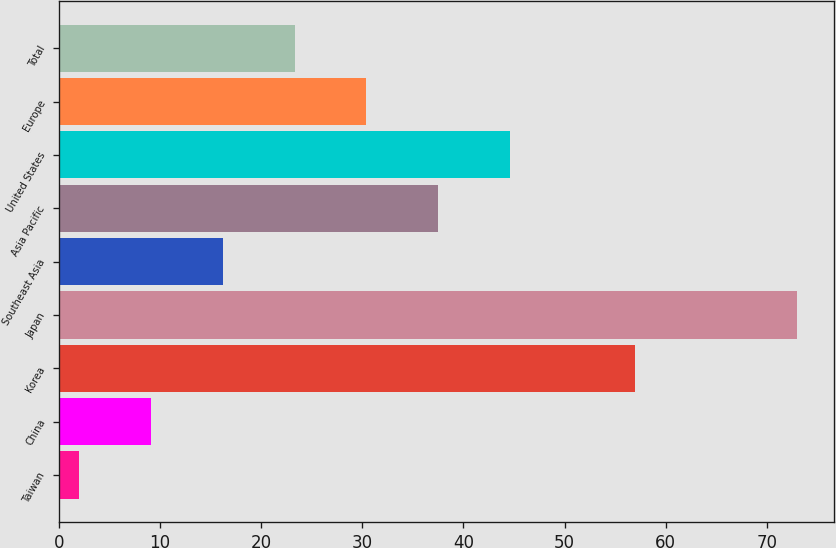<chart> <loc_0><loc_0><loc_500><loc_500><bar_chart><fcel>Taiwan<fcel>China<fcel>Korea<fcel>Japan<fcel>Southeast Asia<fcel>Asia Pacific<fcel>United States<fcel>Europe<fcel>Total<nl><fcel>2<fcel>9.1<fcel>57<fcel>73<fcel>16.2<fcel>37.5<fcel>44.6<fcel>30.4<fcel>23.3<nl></chart> 